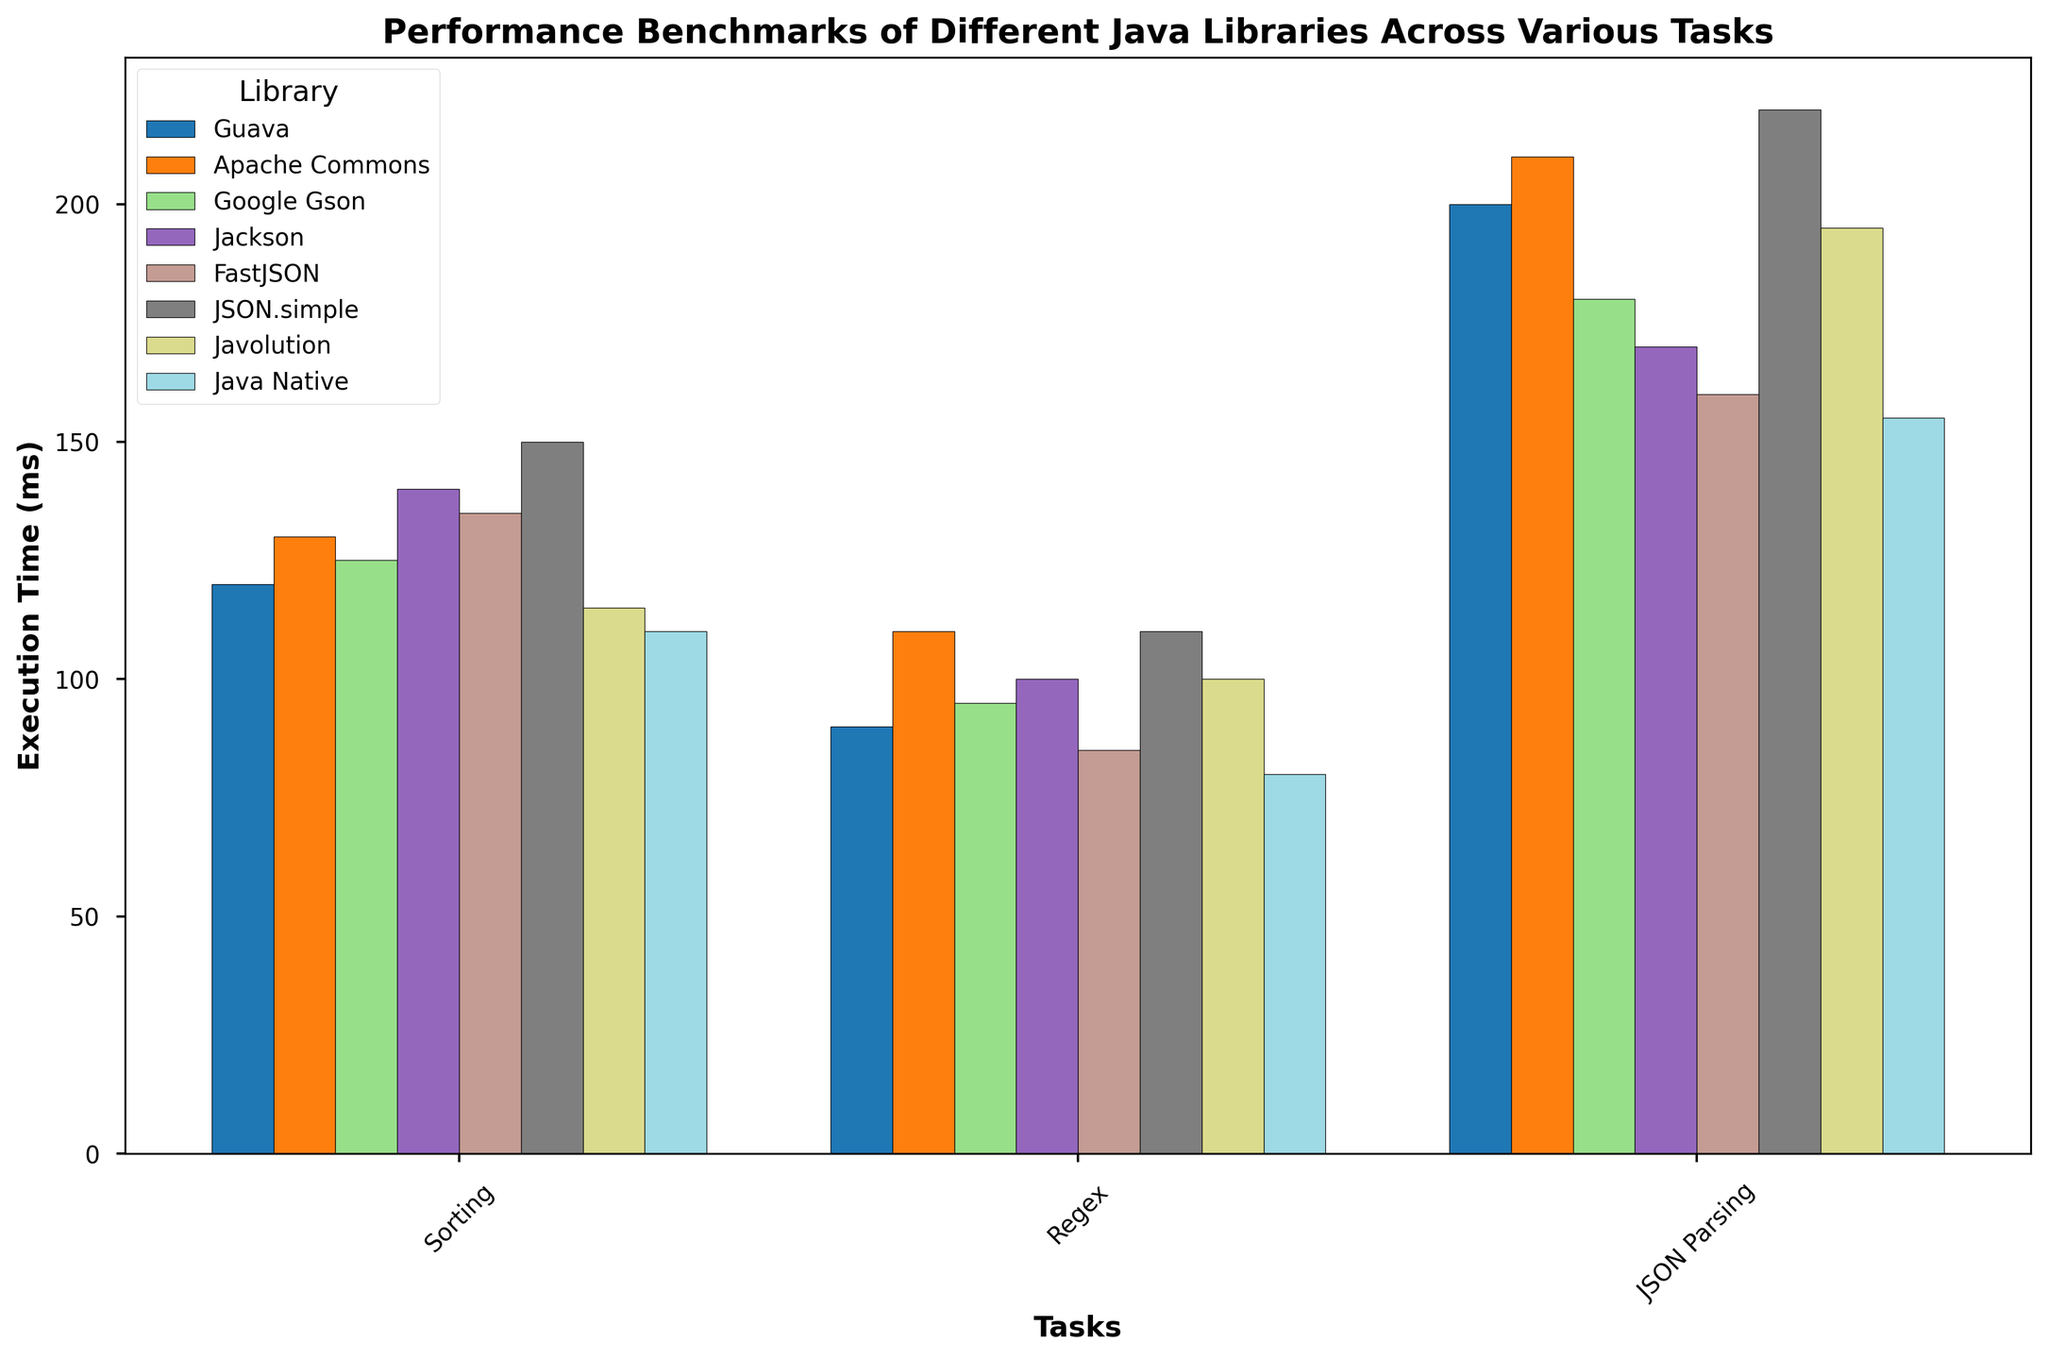What is the execution time for the Guava library in the JSON Parsing task? Look at the bar corresponding to the Guava library under the JSON Parsing task. The height of the bar indicates the execution time.
Answer: 200 ms Which library has the shortest execution time in the Regex task? Compare the heights of all the bars for the Regex task across all the libraries. The shortest bar indicates the shortest execution time.
Answer: Java Native How much faster is the FastJSON library compared to the Jackson library for the JSON Parsing task? Find the execution times for FastJSON (160 ms) and Jackson (170 ms) in the JSON Parsing task. Subtract the execution time of FastJSON from Jackson.
Answer: 10 ms Which task sees the most significant performance difference between the best and worst-performing libraries? For each task, subtract the shortest execution time from the longest execution time. The task with the largest difference is the answer. For Sorting: 150 ms - 110 ms, for Regex: 110 ms - 80 ms, for JSON Parsing: 220 ms - 155 ms.
Answer: JSON Parsing What is the average execution time for the Apache Commons library across all tasks? Add the execution times of Apache Commons for all tasks (130 ms + 110 ms + 210 ms) and divide by the number of tasks (3).
Answer: 150 ms Which library's bars are visually the tallest across all tasks? Compare the bar heights for all tasks visually across all libraries. Identify which library generally has the tallest bars.
Answer: JSON.simple In the Sorting task, which two libraries have the most similar execution times? Compare the heights of the bars under the Sorting task and find the two that look almost equal.
Answer: Guava and Google Gson For the Regex task, how does the performance of the Guava library compare to the average performance of all libraries in this task? Find the execution times for all libraries in Regex: Guava (90 ms), Apache Commons (110 ms), Google Gson (95 ms), Jackson (100 ms), FastJSON (85 ms), JSON.simple (110 ms), Javolution (100 ms), Java Native (80 ms). Calculate the average: (90 + 110 + 95 + 100 + 85 + 110 + 100 + 80)/8 = 96.25 ms. Compare Guava's time to this average.
Answer: Faster What is the difference in execution times between the Java Native and JSON.simple libraries for the Sorting task? Look at the execution times for Java Native (110 ms) and JSON.simple (150 ms) in the Sorting task. Subtract the execution time of Java Native from JSON.simple.
Answer: 40 ms 